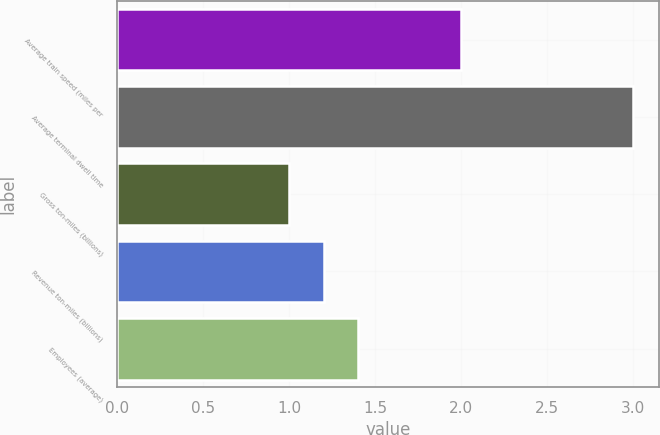Convert chart. <chart><loc_0><loc_0><loc_500><loc_500><bar_chart><fcel>Average train speed (miles per<fcel>Average terminal dwell time<fcel>Gross ton-miles (billions)<fcel>Revenue ton-miles (billions)<fcel>Employees (average)<nl><fcel>2<fcel>3<fcel>1<fcel>1.2<fcel>1.4<nl></chart> 